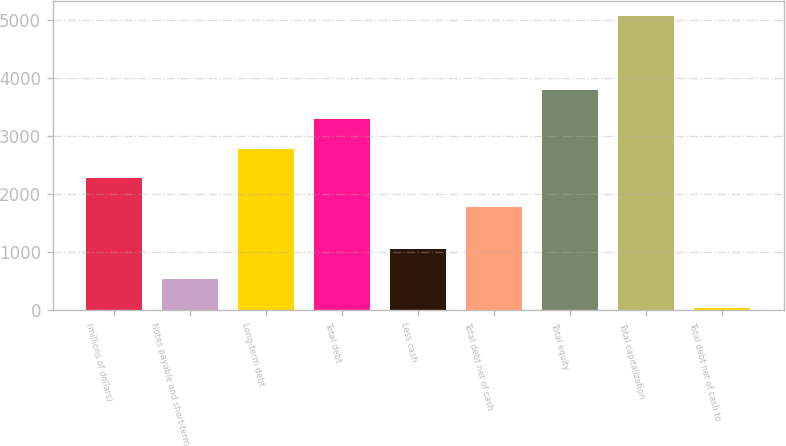<chart> <loc_0><loc_0><loc_500><loc_500><bar_chart><fcel>(millions of dollars)<fcel>Notes payable and short-term<fcel>Long-term debt<fcel>Total debt<fcel>Less cash<fcel>Total debt net of cash<fcel>Total equity<fcel>Total capitalization<fcel>Total debt net of cash to<nl><fcel>2280.07<fcel>539.27<fcel>2784.34<fcel>3288.61<fcel>1043.54<fcel>1775.8<fcel>3792.88<fcel>5077.7<fcel>35<nl></chart> 